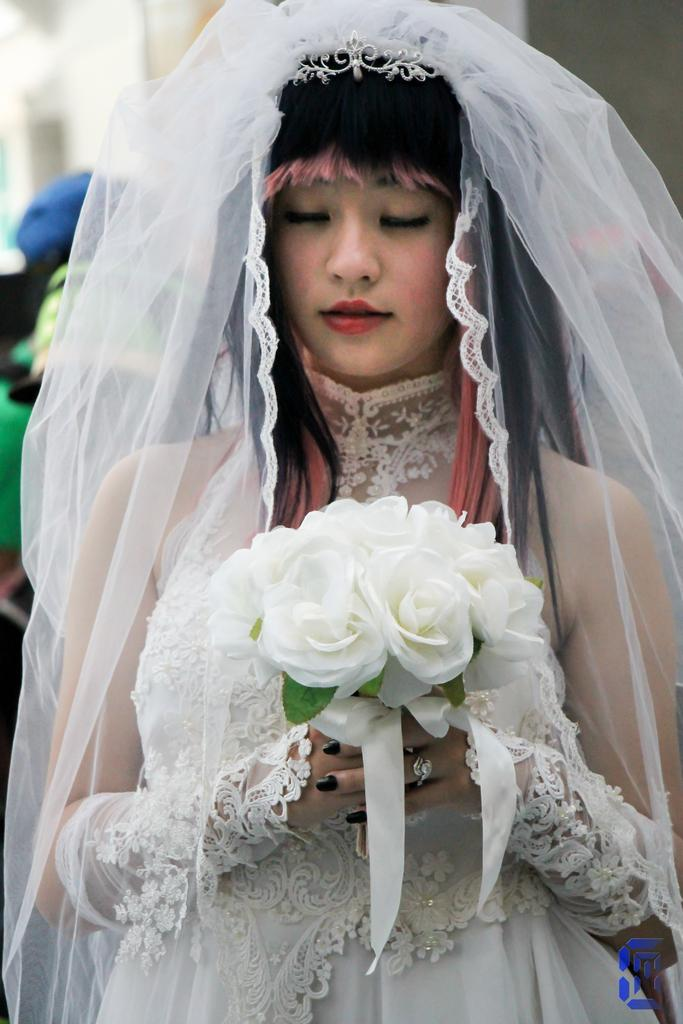What is the main subject of the image? There is a woman in the image. What is the woman doing in the image? The woman is standing and holding flowers in her hands. How is the woman dressed in the image? The woman is wearing a cloth on her head. Can you describe the background of the image? There is a building in the background of the image. Are there any other people in the image besides the woman? Yes, there is another human in the image. What type of knot is the woman using to secure the cloth on her head? The image does not provide enough detail to determine the type of knot used to secure the cloth on the woman's head. How many giants can be seen in the image? There are no giants present in the image. 